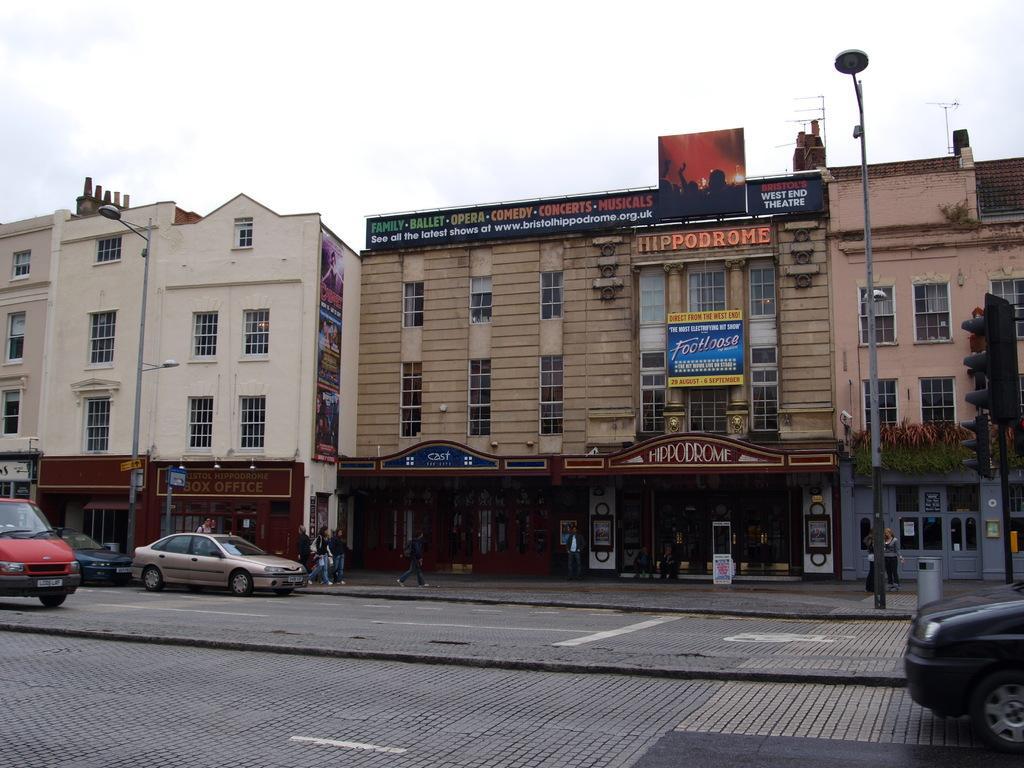Can you describe this image briefly? In this picture I can see few vehicles are on the road, side there are some building and few people are walking side of the road. 